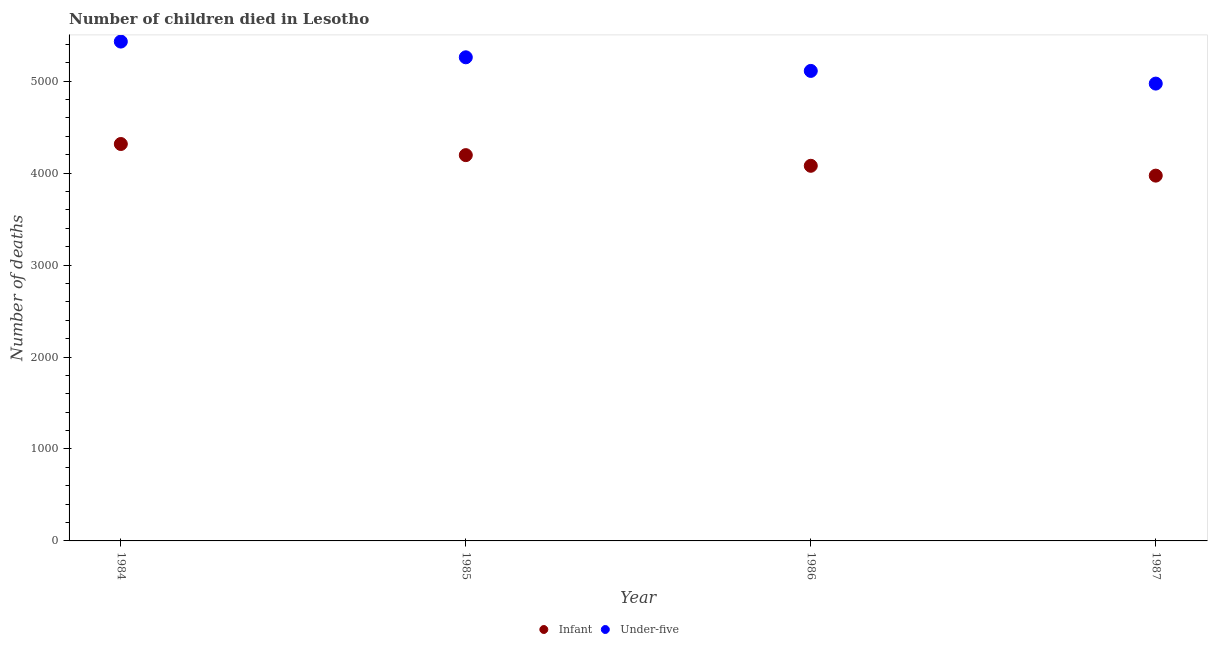Is the number of dotlines equal to the number of legend labels?
Keep it short and to the point. Yes. What is the number of under-five deaths in 1987?
Your answer should be very brief. 4974. Across all years, what is the maximum number of under-five deaths?
Your answer should be very brief. 5431. Across all years, what is the minimum number of under-five deaths?
Keep it short and to the point. 4974. In which year was the number of under-five deaths maximum?
Your response must be concise. 1984. What is the total number of infant deaths in the graph?
Ensure brevity in your answer.  1.66e+04. What is the difference between the number of infant deaths in 1985 and that in 1986?
Provide a succinct answer. 116. What is the difference between the number of infant deaths in 1987 and the number of under-five deaths in 1986?
Keep it short and to the point. -1139. What is the average number of infant deaths per year?
Your response must be concise. 4141.5. In the year 1985, what is the difference between the number of under-five deaths and number of infant deaths?
Keep it short and to the point. 1064. What is the ratio of the number of under-five deaths in 1984 to that in 1986?
Provide a succinct answer. 1.06. Is the number of infant deaths in 1984 less than that in 1987?
Offer a terse response. No. Is the difference between the number of under-five deaths in 1985 and 1987 greater than the difference between the number of infant deaths in 1985 and 1987?
Offer a very short reply. Yes. What is the difference between the highest and the second highest number of under-five deaths?
Ensure brevity in your answer.  171. What is the difference between the highest and the lowest number of under-five deaths?
Your answer should be compact. 457. Does the number of infant deaths monotonically increase over the years?
Provide a short and direct response. No. Is the number of under-five deaths strictly less than the number of infant deaths over the years?
Your answer should be compact. No. What is the difference between two consecutive major ticks on the Y-axis?
Provide a succinct answer. 1000. Does the graph contain any zero values?
Provide a succinct answer. No. Does the graph contain grids?
Offer a very short reply. No. Where does the legend appear in the graph?
Your answer should be compact. Bottom center. How many legend labels are there?
Offer a terse response. 2. How are the legend labels stacked?
Provide a short and direct response. Horizontal. What is the title of the graph?
Your answer should be very brief. Number of children died in Lesotho. What is the label or title of the X-axis?
Your answer should be compact. Year. What is the label or title of the Y-axis?
Your response must be concise. Number of deaths. What is the Number of deaths of Infant in 1984?
Your response must be concise. 4317. What is the Number of deaths of Under-five in 1984?
Make the answer very short. 5431. What is the Number of deaths of Infant in 1985?
Make the answer very short. 4196. What is the Number of deaths in Under-five in 1985?
Your answer should be compact. 5260. What is the Number of deaths in Infant in 1986?
Your response must be concise. 4080. What is the Number of deaths of Under-five in 1986?
Offer a terse response. 5112. What is the Number of deaths of Infant in 1987?
Provide a succinct answer. 3973. What is the Number of deaths in Under-five in 1987?
Your answer should be compact. 4974. Across all years, what is the maximum Number of deaths in Infant?
Offer a very short reply. 4317. Across all years, what is the maximum Number of deaths in Under-five?
Offer a terse response. 5431. Across all years, what is the minimum Number of deaths of Infant?
Make the answer very short. 3973. Across all years, what is the minimum Number of deaths in Under-five?
Your answer should be compact. 4974. What is the total Number of deaths in Infant in the graph?
Provide a succinct answer. 1.66e+04. What is the total Number of deaths in Under-five in the graph?
Offer a very short reply. 2.08e+04. What is the difference between the Number of deaths of Infant in 1984 and that in 1985?
Ensure brevity in your answer.  121. What is the difference between the Number of deaths in Under-five in 1984 and that in 1985?
Keep it short and to the point. 171. What is the difference between the Number of deaths in Infant in 1984 and that in 1986?
Keep it short and to the point. 237. What is the difference between the Number of deaths of Under-five in 1984 and that in 1986?
Your answer should be compact. 319. What is the difference between the Number of deaths of Infant in 1984 and that in 1987?
Ensure brevity in your answer.  344. What is the difference between the Number of deaths in Under-five in 1984 and that in 1987?
Give a very brief answer. 457. What is the difference between the Number of deaths of Infant in 1985 and that in 1986?
Make the answer very short. 116. What is the difference between the Number of deaths of Under-five in 1985 and that in 1986?
Provide a succinct answer. 148. What is the difference between the Number of deaths of Infant in 1985 and that in 1987?
Your response must be concise. 223. What is the difference between the Number of deaths in Under-five in 1985 and that in 1987?
Your answer should be very brief. 286. What is the difference between the Number of deaths of Infant in 1986 and that in 1987?
Give a very brief answer. 107. What is the difference between the Number of deaths of Under-five in 1986 and that in 1987?
Keep it short and to the point. 138. What is the difference between the Number of deaths of Infant in 1984 and the Number of deaths of Under-five in 1985?
Offer a terse response. -943. What is the difference between the Number of deaths of Infant in 1984 and the Number of deaths of Under-five in 1986?
Give a very brief answer. -795. What is the difference between the Number of deaths in Infant in 1984 and the Number of deaths in Under-five in 1987?
Keep it short and to the point. -657. What is the difference between the Number of deaths in Infant in 1985 and the Number of deaths in Under-five in 1986?
Your answer should be compact. -916. What is the difference between the Number of deaths in Infant in 1985 and the Number of deaths in Under-five in 1987?
Give a very brief answer. -778. What is the difference between the Number of deaths in Infant in 1986 and the Number of deaths in Under-five in 1987?
Make the answer very short. -894. What is the average Number of deaths in Infant per year?
Give a very brief answer. 4141.5. What is the average Number of deaths of Under-five per year?
Give a very brief answer. 5194.25. In the year 1984, what is the difference between the Number of deaths in Infant and Number of deaths in Under-five?
Provide a short and direct response. -1114. In the year 1985, what is the difference between the Number of deaths in Infant and Number of deaths in Under-five?
Your response must be concise. -1064. In the year 1986, what is the difference between the Number of deaths of Infant and Number of deaths of Under-five?
Give a very brief answer. -1032. In the year 1987, what is the difference between the Number of deaths in Infant and Number of deaths in Under-five?
Offer a very short reply. -1001. What is the ratio of the Number of deaths in Infant in 1984 to that in 1985?
Give a very brief answer. 1.03. What is the ratio of the Number of deaths of Under-five in 1984 to that in 1985?
Offer a terse response. 1.03. What is the ratio of the Number of deaths in Infant in 1984 to that in 1986?
Offer a very short reply. 1.06. What is the ratio of the Number of deaths in Under-five in 1984 to that in 1986?
Ensure brevity in your answer.  1.06. What is the ratio of the Number of deaths in Infant in 1984 to that in 1987?
Provide a succinct answer. 1.09. What is the ratio of the Number of deaths in Under-five in 1984 to that in 1987?
Provide a short and direct response. 1.09. What is the ratio of the Number of deaths of Infant in 1985 to that in 1986?
Provide a succinct answer. 1.03. What is the ratio of the Number of deaths in Under-five in 1985 to that in 1986?
Provide a succinct answer. 1.03. What is the ratio of the Number of deaths of Infant in 1985 to that in 1987?
Provide a short and direct response. 1.06. What is the ratio of the Number of deaths of Under-five in 1985 to that in 1987?
Your answer should be compact. 1.06. What is the ratio of the Number of deaths of Infant in 1986 to that in 1987?
Offer a very short reply. 1.03. What is the ratio of the Number of deaths of Under-five in 1986 to that in 1987?
Keep it short and to the point. 1.03. What is the difference between the highest and the second highest Number of deaths in Infant?
Your response must be concise. 121. What is the difference between the highest and the second highest Number of deaths of Under-five?
Make the answer very short. 171. What is the difference between the highest and the lowest Number of deaths in Infant?
Offer a very short reply. 344. What is the difference between the highest and the lowest Number of deaths of Under-five?
Provide a short and direct response. 457. 